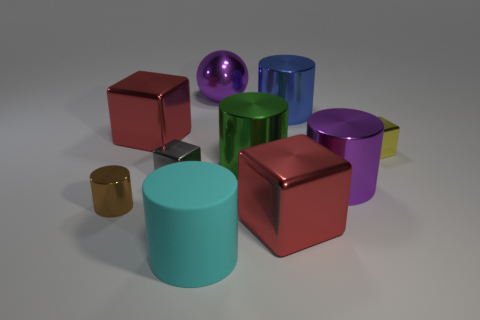Is there anything else that has the same size as the green metal object?
Give a very brief answer. Yes. There is a large red object on the left side of the big cyan thing; is its shape the same as the matte thing?
Offer a very short reply. No. The big rubber object has what color?
Provide a short and direct response. Cyan. There is another big rubber object that is the same shape as the large green thing; what is its color?
Provide a succinct answer. Cyan. How many small brown metallic objects are the same shape as the gray thing?
Ensure brevity in your answer.  0. How many things are cyan things or blocks that are left of the large blue cylinder?
Offer a terse response. 4. There is a big metallic sphere; is its color the same as the big metal cylinder that is in front of the gray metal block?
Ensure brevity in your answer.  Yes. There is a shiny cube that is left of the purple metallic cylinder and right of the sphere; what is its size?
Ensure brevity in your answer.  Large. Are there any small yellow objects in front of the small brown shiny thing?
Offer a very short reply. No. There is a red metal block in front of the tiny yellow metallic object; is there a purple metal thing that is on the left side of it?
Offer a terse response. Yes. 